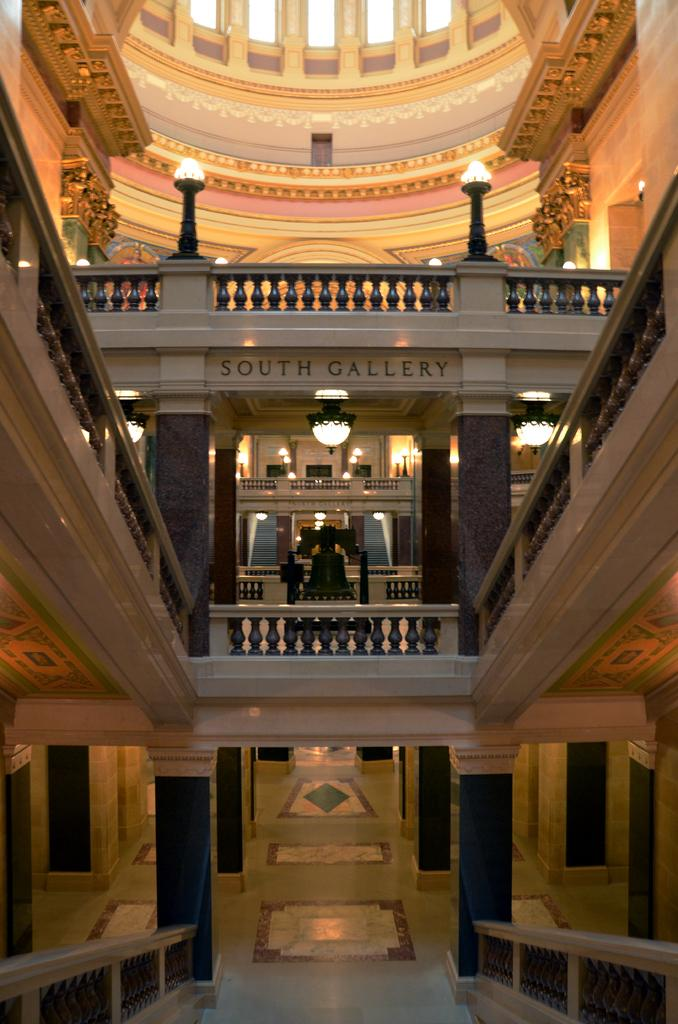What type of structure is present in the image? There is a building in the image. What can be seen in the background of the image? There are lights visible in the background of the image. How would you describe the color of the wall in the image? The wall has a brown and cream color. How many rabbits are sitting on the roof of the building in the image? There are no rabbits present in the image, so it is not possible to determine how many might be on the roof. 